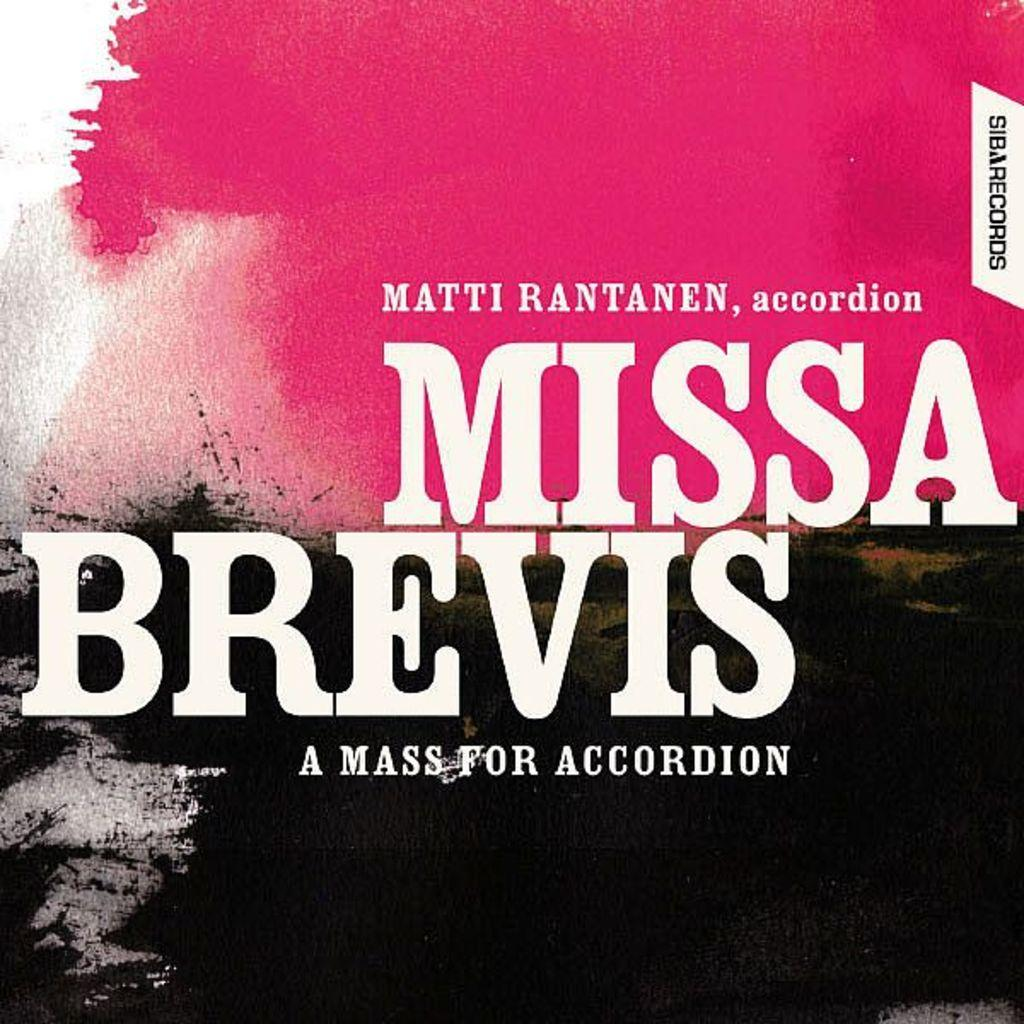What is the main focus of the image? There is text or an image in the center of the image. What colors can be seen in the background of the image? The background of the image has pink, white, and black colors. What grade did the sister receive in the image? There is no mention of a sister or a grade in the image. The image only contains text or an image in the center and a background with pink, white, and black colors. 